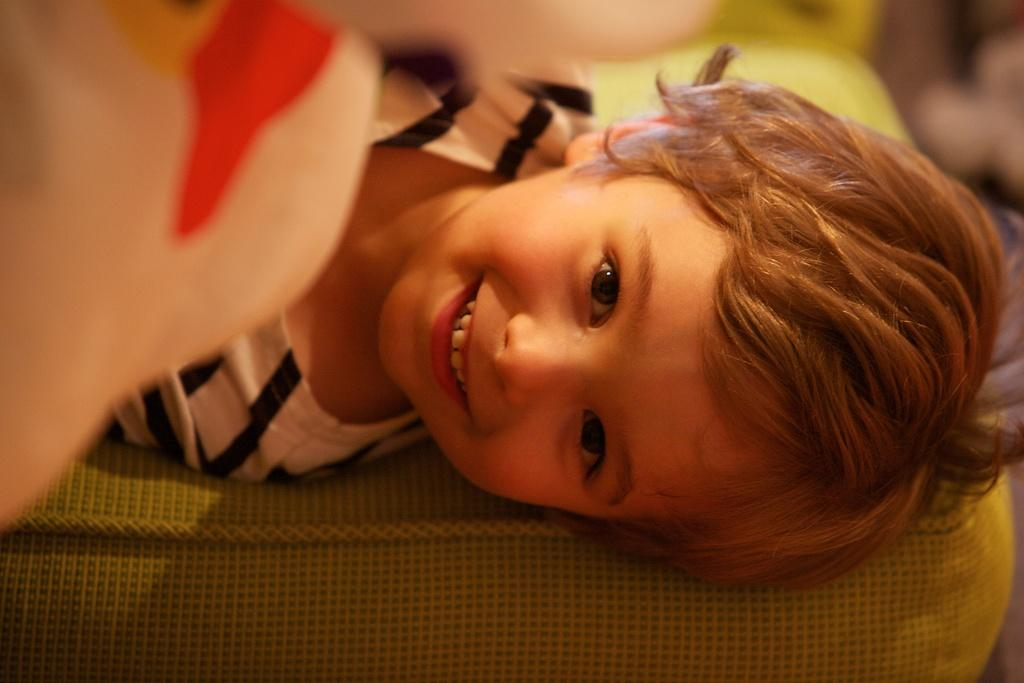What is the main subject of the image? There is a kid in the center of the image. What is the kid's expression in the image? The kid is smiling. What is located at the bottom of the image? There is a cushion at the bottom of the image. How many babies are present in the image? There are no babies mentioned or visible in the image; it features a kid. What story is the kid telling in the image? There is no indication of a story being told in the image; the kid is simply smiling. 